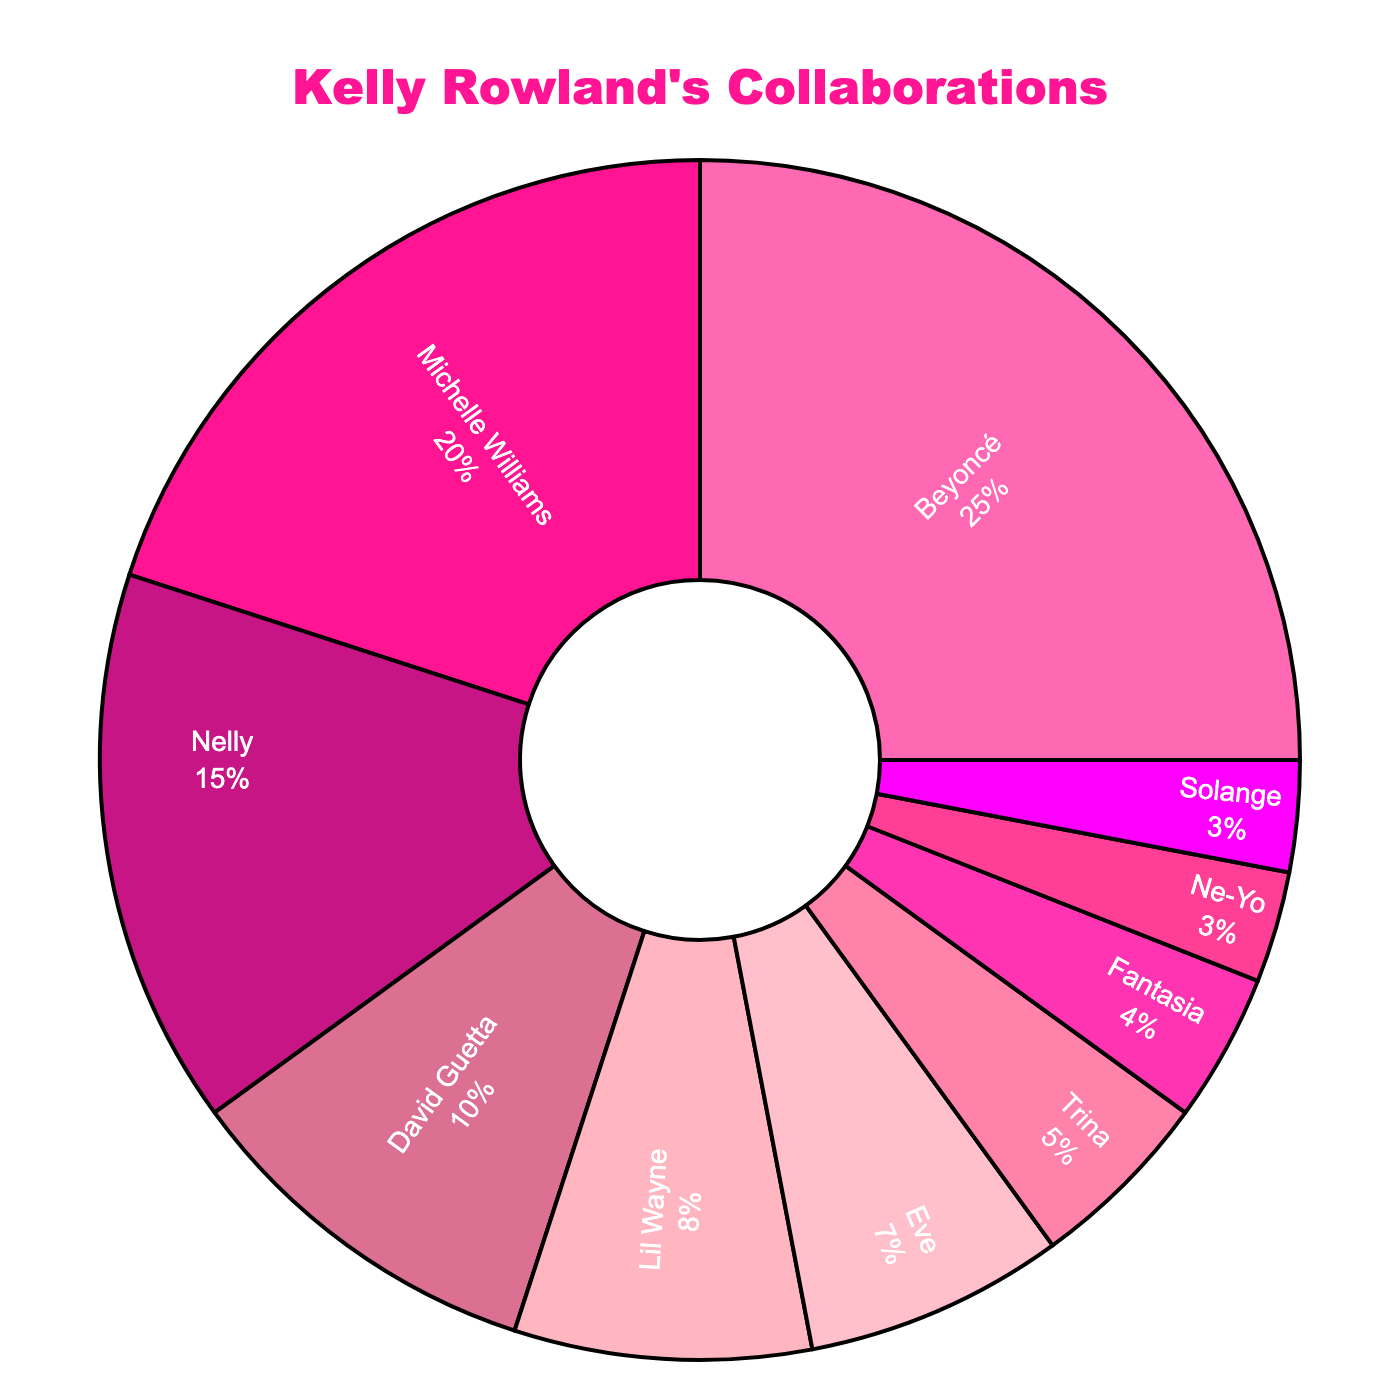What's the artist with whom Kelly Rowland has collaborated the most? Looking at the pie chart, the largest segment represents the artist Kelly Rowland collaborated most with, which is depicted at 25%. That artist is Beyoncé.
Answer: Beyoncé What percentage of Kelly Rowland's collaborations were with Beyoncé and Nelly combined? To find the combined percentage, sum the individual percentages for Beyoncé (25%) and Nelly (15%). That sums up to 25 + 15 = 40%.
Answer: 40% How does Michelle Williams' collaboration percentage compare to David Guetta's? Michelle Williams has 20% while David Guetta has 10%. By comparison, Michelle Williams' percentage (20%) is double that of David Guetta's (10%).
Answer: Michelle Williams' percentage is double David Guetta's Which artist has the lowest collaboration percentage with Kelly Rowland, and what is it? The smallest segment in the pie chart represents the artist with the lowest percentage. Solange and Ne-Yo both have the lowest percentages at 3%.
Answer: Solange and Ne-Yo, 3% How does the sum of the collaborations with Nelly, David Guetta, and Lil Wayne compare to those with Eve and Trina? First, sum the percentages for Nelly (15%), David Guetta (10%), and Lil Wayne (8%), which is 15 + 10 + 8 = 33%. Next, sum the percentages for Eve (7%) and Trina (5%), which is 7 + 5 = 12%. The first sum (33%) is significantly higher than the second sum (12%).
Answer: Nelly, David Guetta, and Lil Wayne sum is higher (33%) than Eve and Trina (12%) Describe the color used in the segment for Michelle Williams' collaborations. The segment for Michelle Williams is a darker shade of pink.
Answer: Dark pink How many artists, including Beyoncé, have a collaboration percentage of 10% or more? The segments for Beyoncé (25%), Michelle Williams (20%), Nelly (15%), and David Guetta (10%) each have collaboration percentages of 10% or more. There are 4 such artists.
Answer: 4 artists What is the difference in collaboration percentages between Trina and Fantasia? The collaboration percentages for Trina and Fantasia are 5% and 4%, respectively. The difference is 5 - 4 = 1%.
Answer: 1% If you combine all collaborations with Destiny's Child members (Beyoncé, Michelle Williams, and Solange), what would be the total percentage? Sum the percentages for Beyoncé (25%), Michelle Williams (20%), and Solange (3%). This equals 25 + 20 + 3 = 48%.
Answer: 48% What is the visual orientation of the text inside the pie segments, and what color is the text? The text is positioned inside the segments and oriented radially. The color of the text is white.
Answer: Radial orientation, white text 